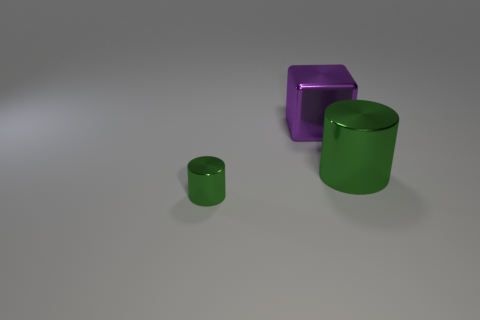How many other objects are the same color as the small thing?
Offer a terse response. 1. There is a green thing on the left side of the large metallic cylinder; what shape is it?
Ensure brevity in your answer.  Cylinder. How many objects are large purple objects or tiny purple balls?
Give a very brief answer. 1. Do the metallic block and the green metallic cylinder that is left of the cube have the same size?
Offer a very short reply. No. How many other objects are there of the same material as the big green object?
Provide a succinct answer. 2. How many things are either green metal cylinders on the right side of the large metallic cube or big metal objects that are to the left of the large metallic cylinder?
Give a very brief answer. 2. There is a large green object that is the same shape as the tiny metal object; what is it made of?
Keep it short and to the point. Metal. Is there a big yellow cube?
Provide a short and direct response. No. What is the size of the object that is on the right side of the small cylinder and in front of the metal cube?
Offer a very short reply. Large. The big purple thing has what shape?
Make the answer very short. Cube. 